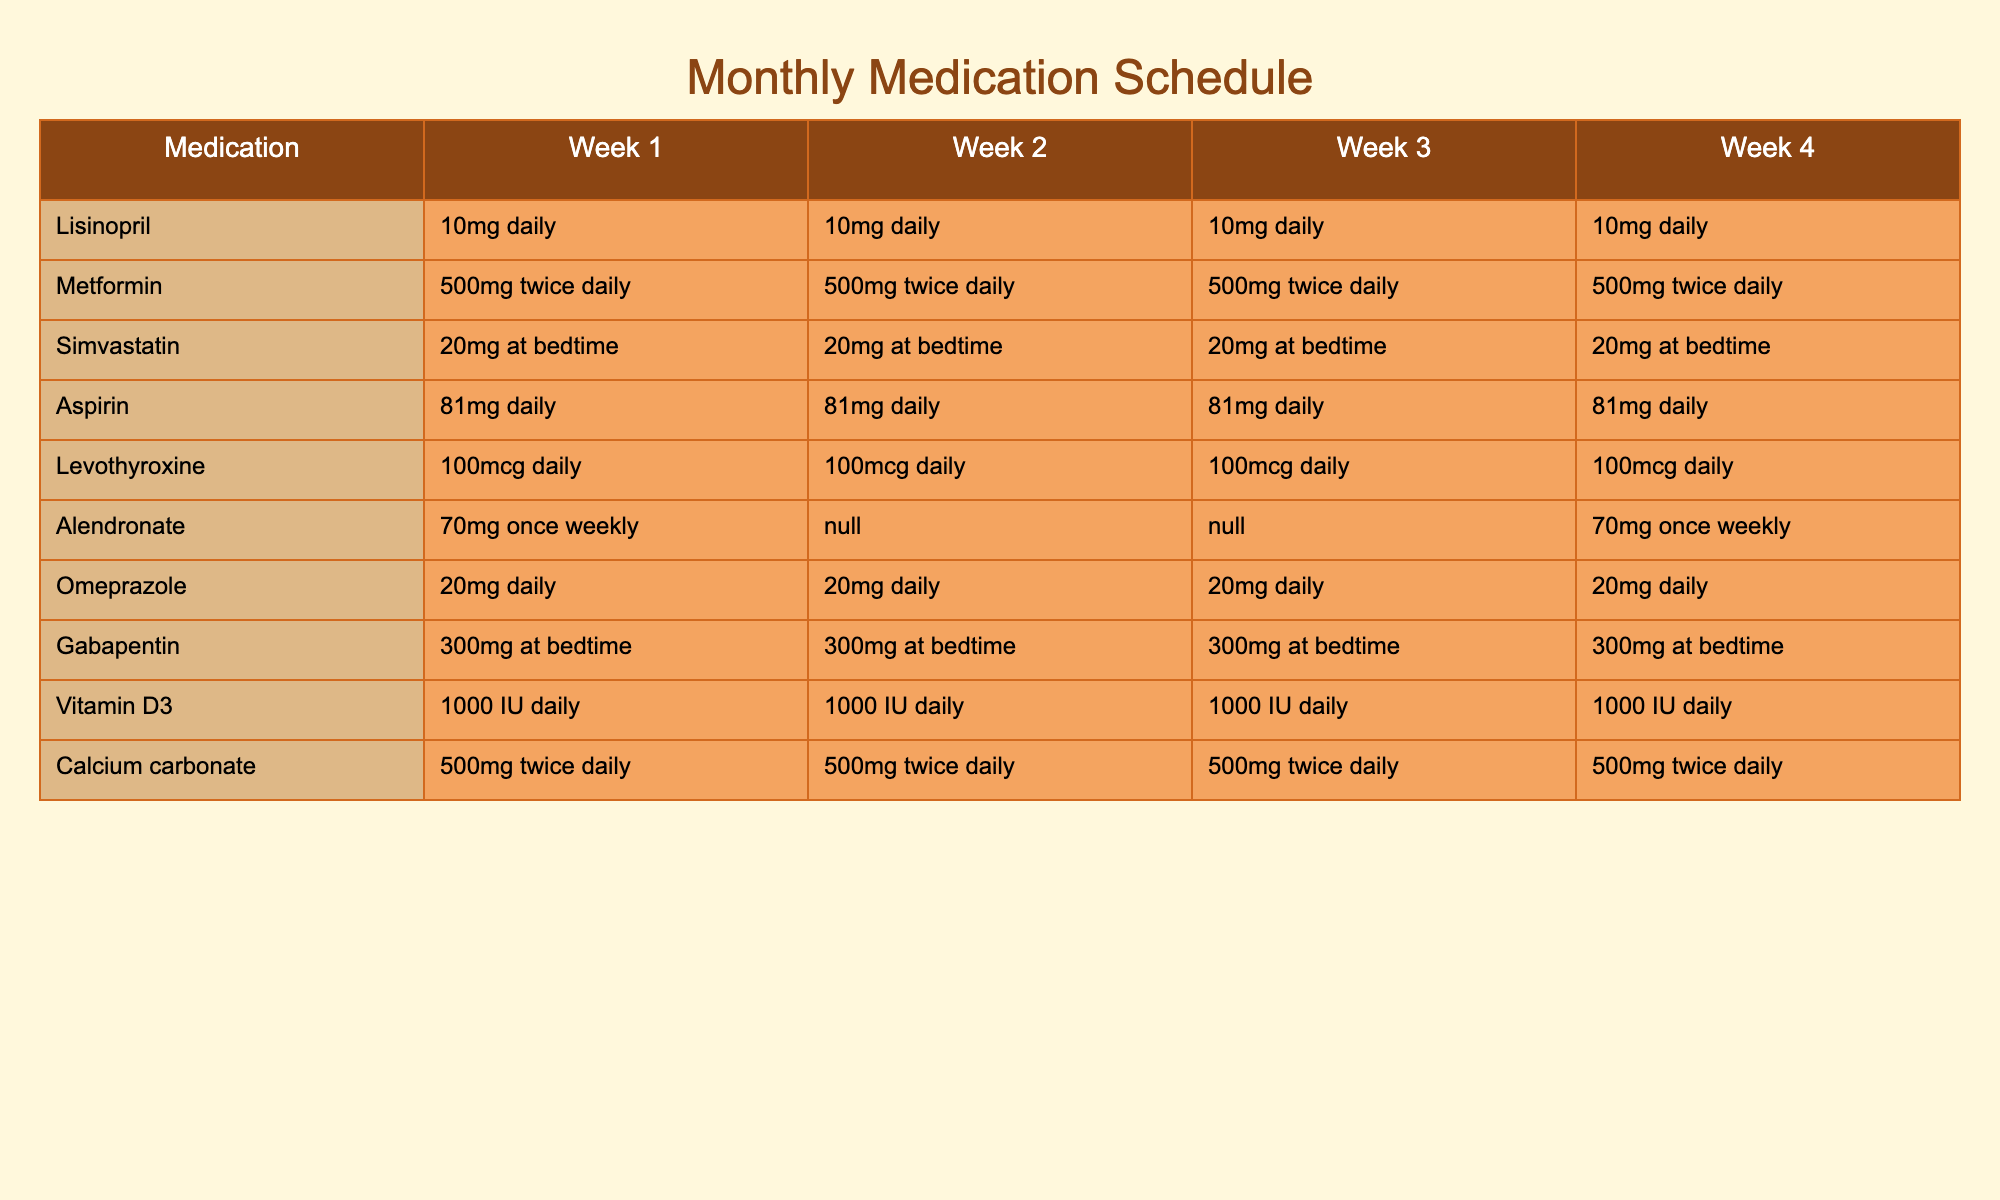What is the recommended dosage of Lisinopril for all four weeks? The table shows that for Lisinopril, the dosage is consistently 10mg daily for all four weeks.
Answer: 10mg daily How many times a day is Metformin taken? The table indicates that Metformin is taken twice daily for all four weeks.
Answer: Twice daily Does Gabapentin have the same dosage throughout the month? Yes, the table shows that Gabapentin is prescribed as 300mg at bedtime for all four weeks.
Answer: Yes Which medication is only taken once a week, and in what week is it taken? The table indicates that Alendronate is taken once weekly, specifically in Week 1 and Week 4.
Answer: Alendronate, Week 1 and Week 4 If a patient takes all their medications listed, how many total doses of Calcium carbonate do they take in a week? Calcium carbonate is taken twice daily, resulting in 2 doses per day. Therefore, over 7 days the total is 2 doses x 7 days = 14 doses.
Answer: 14 doses Is Levothyroxine taken more than once daily? The table shows that Levothyroxine is taken daily, but only once per day.
Answer: No What is the total daily dosage of Aspirin for Week 2? The table indicates Aspirin is prescribed as 81mg daily. The total for Week 2 is 81mg since it's taken once a day.
Answer: 81mg Which medication has a dosage that changes between weeks? The table does not show any changes in dosage for the medications listed; all have consistent dosages throughout the weeks.
Answer: None If a patient follows the whole month schedule for Vitamin D3, how many total units will they consume? Vitamin D3 is prescribed at 1000 IU daily. The total consumption for 4 weeks (28 days) is 1000 IU x 28 days = 28,000 IU.
Answer: 28,000 IU What percentage of medications are taken daily? There are 10 medications listed, and 7 of them are taken daily. Thus, the percentage is (7/10) x 100 = 70%.
Answer: 70% 